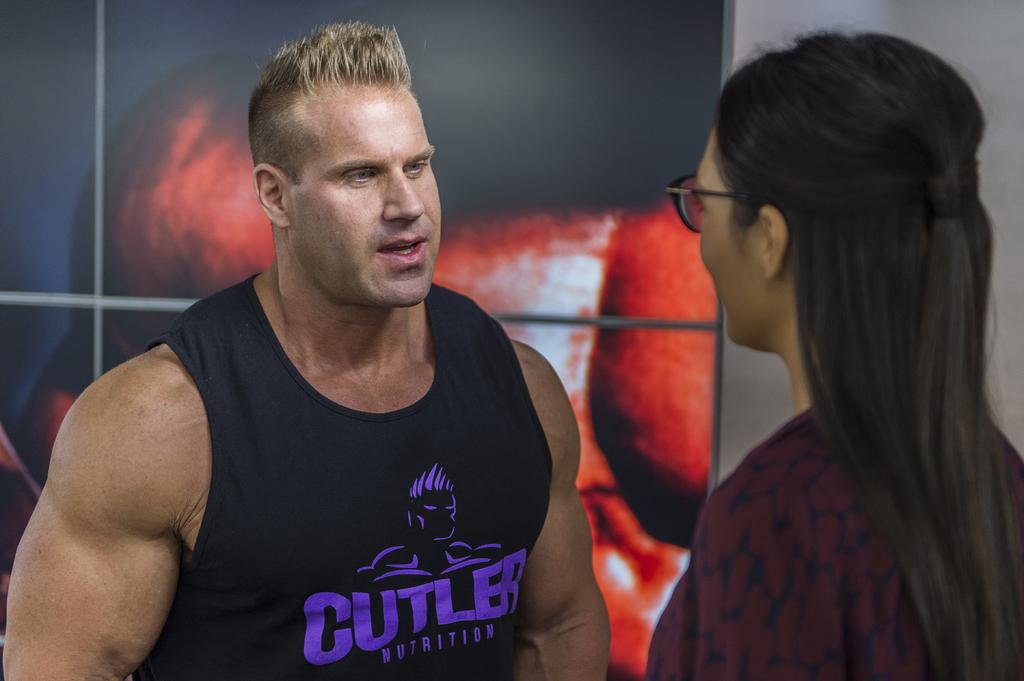<image>
Render a clear and concise summary of the photo. A muscular man in a Cutler Nutrition tank top speaks to a woman. 